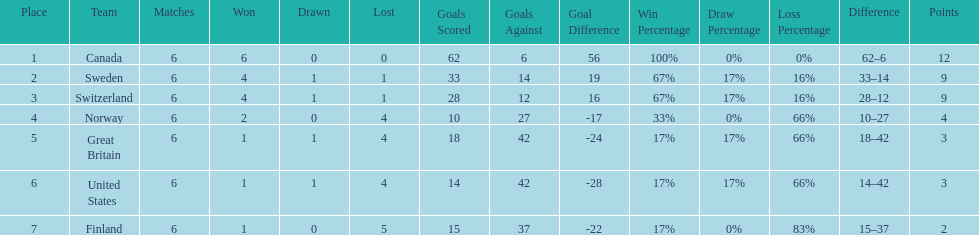Which country performed better during the 1951 world ice hockey championships, switzerland or great britain? Switzerland. 